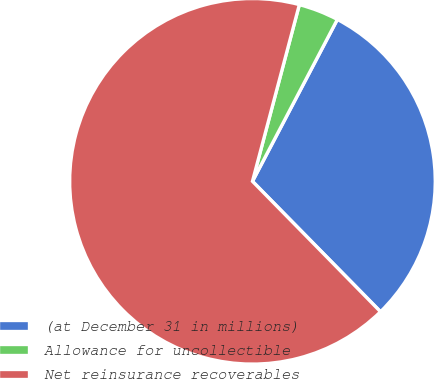<chart> <loc_0><loc_0><loc_500><loc_500><pie_chart><fcel>(at December 31 in millions)<fcel>Allowance for uncollectible<fcel>Net reinsurance recoverables<nl><fcel>29.96%<fcel>3.56%<fcel>66.49%<nl></chart> 